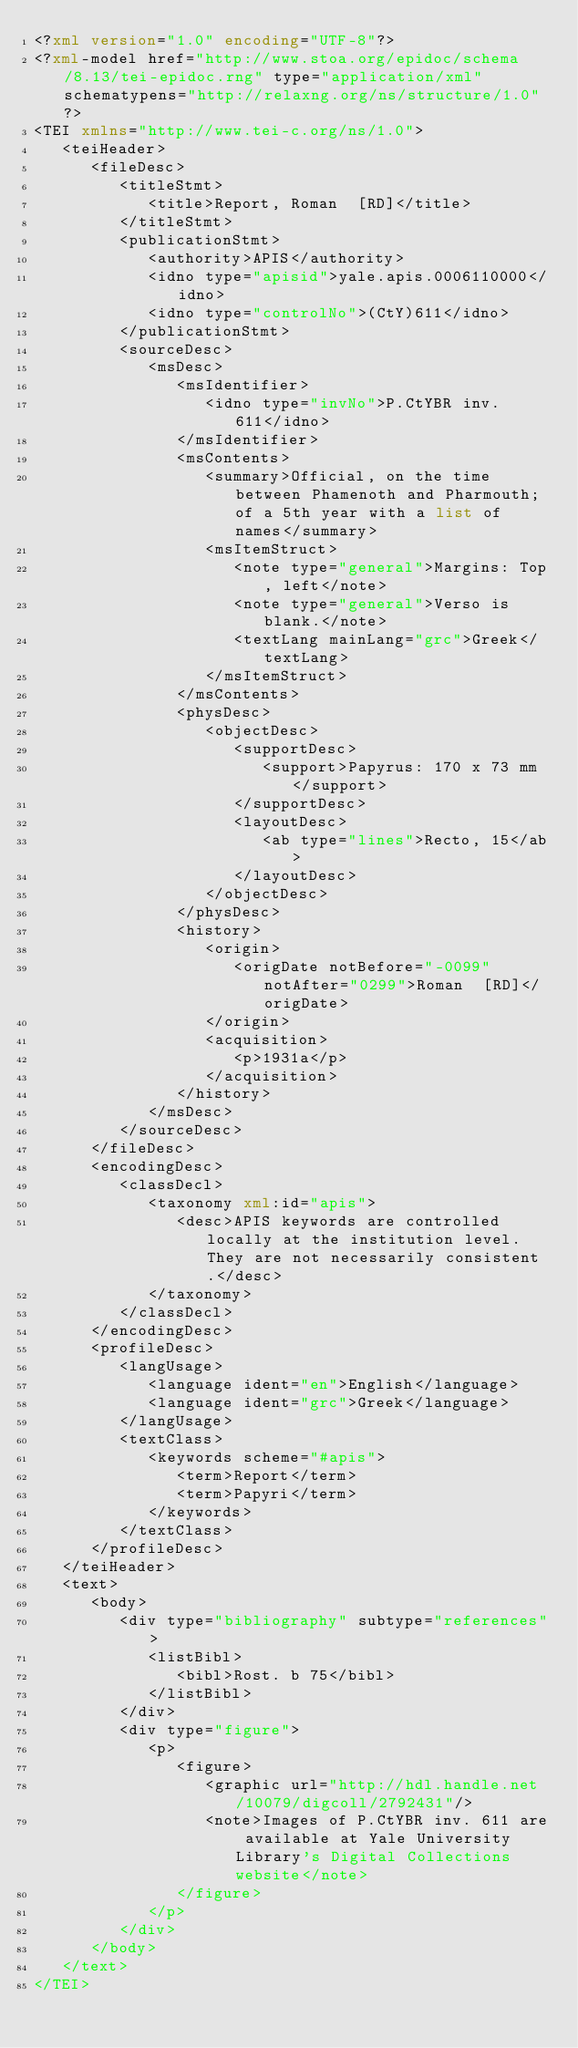<code> <loc_0><loc_0><loc_500><loc_500><_XML_><?xml version="1.0" encoding="UTF-8"?>
<?xml-model href="http://www.stoa.org/epidoc/schema/8.13/tei-epidoc.rng" type="application/xml" schematypens="http://relaxng.org/ns/structure/1.0"?>
<TEI xmlns="http://www.tei-c.org/ns/1.0">
   <teiHeader>
      <fileDesc>
         <titleStmt>
            <title>Report, Roman  [RD]</title>
         </titleStmt>
         <publicationStmt>
            <authority>APIS</authority>
            <idno type="apisid">yale.apis.0006110000</idno>
            <idno type="controlNo">(CtY)611</idno>
         </publicationStmt>
         <sourceDesc>
            <msDesc>
               <msIdentifier>
                  <idno type="invNo">P.CtYBR inv. 611</idno>
               </msIdentifier>
               <msContents>
                  <summary>Official, on the time between Phamenoth and Pharmouth; of a 5th year with a list of names</summary>
                  <msItemStruct>
                     <note type="general">Margins: Top, left</note>
                     <note type="general">Verso is blank.</note>
                     <textLang mainLang="grc">Greek</textLang>
                  </msItemStruct>
               </msContents>
               <physDesc>
                  <objectDesc>
                     <supportDesc>
                        <support>Papyrus: 170 x 73 mm</support>
                     </supportDesc>
                     <layoutDesc>
                        <ab type="lines">Recto, 15</ab>
                     </layoutDesc>
                  </objectDesc>
               </physDesc>
               <history>
                  <origin>
                     <origDate notBefore="-0099" notAfter="0299">Roman  [RD]</origDate>
                  </origin>
                  <acquisition>
                     <p>1931a</p>
                  </acquisition>
               </history>
            </msDesc>
         </sourceDesc>
      </fileDesc>
      <encodingDesc>
         <classDecl>
            <taxonomy xml:id="apis">
               <desc>APIS keywords are controlled locally at the institution level. They are not necessarily consistent.</desc>
            </taxonomy>
         </classDecl>
      </encodingDesc>
      <profileDesc>
         <langUsage>
            <language ident="en">English</language>
            <language ident="grc">Greek</language>
         </langUsage>
         <textClass>
            <keywords scheme="#apis">
               <term>Report</term>
               <term>Papyri</term>
            </keywords>
         </textClass>
      </profileDesc>
   </teiHeader>
   <text>
      <body>
         <div type="bibliography" subtype="references">
            <listBibl>
               <bibl>Rost. b 75</bibl>
            </listBibl>
         </div>
         <div type="figure">
            <p>
               <figure>
                  <graphic url="http://hdl.handle.net/10079/digcoll/2792431"/>
                  <note>Images of P.CtYBR inv. 611 are available at Yale University Library's Digital Collections website</note>
               </figure>
            </p>
         </div>
      </body>
   </text>
</TEI>
</code> 